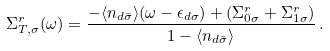<formula> <loc_0><loc_0><loc_500><loc_500>\Sigma _ { T , \sigma } ^ { r } ( \omega ) = \frac { - \langle n _ { d \bar { \sigma } } \rangle ( \omega - \epsilon _ { d \sigma } ) + ( \Sigma _ { 0 \sigma } ^ { r } + \Sigma _ { 1 \sigma } ^ { r } ) } { 1 - \langle n _ { d \bar { \sigma } } \rangle } \, .</formula> 